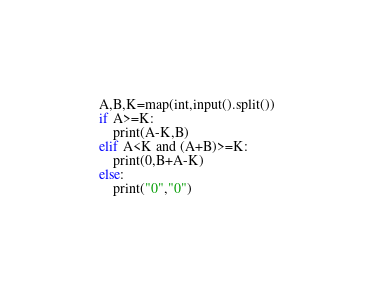<code> <loc_0><loc_0><loc_500><loc_500><_Python_>A,B,K=map(int,input().split())
if A>=K:
    print(A-K,B)
elif A<K and (A+B)>=K:
    print(0,B+A-K)
else:
    print("0","0")</code> 